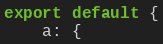Convert code to text. <code><loc_0><loc_0><loc_500><loc_500><_JavaScript_>export default {
    a: {</code> 